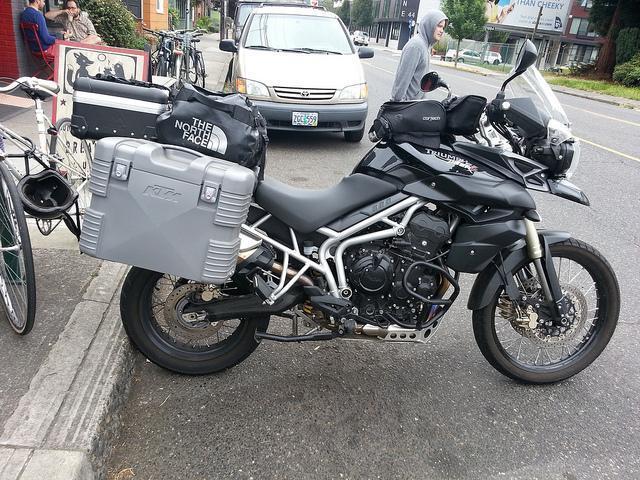How many tires does the bike have?
Give a very brief answer. 2. How many steps are there?
Give a very brief answer. 1. 